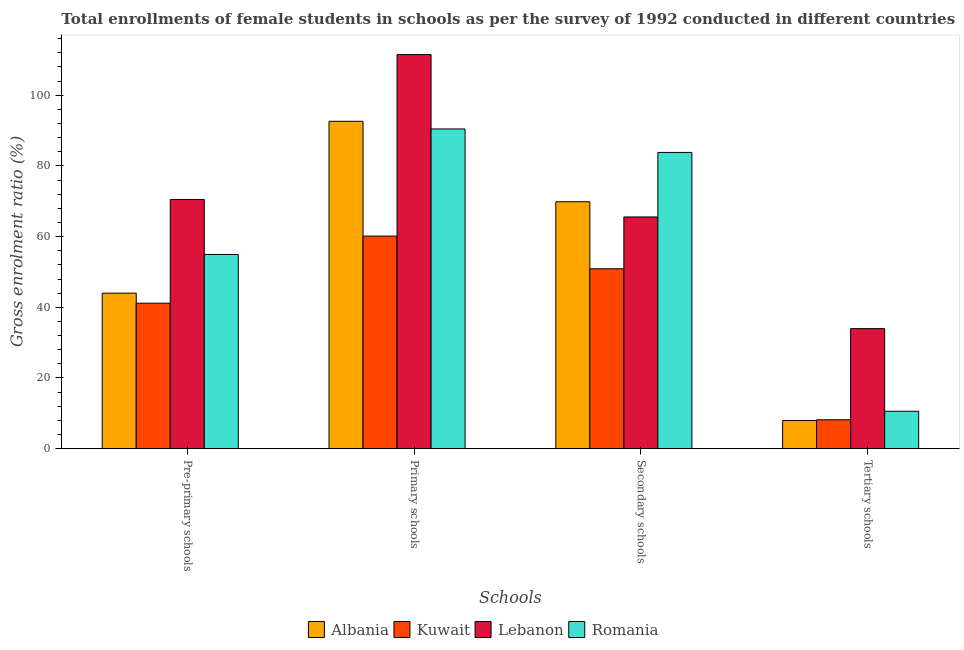How many different coloured bars are there?
Offer a very short reply. 4. How many groups of bars are there?
Provide a short and direct response. 4. How many bars are there on the 1st tick from the left?
Offer a terse response. 4. What is the label of the 4th group of bars from the left?
Your answer should be very brief. Tertiary schools. What is the gross enrolment ratio(female) in tertiary schools in Romania?
Provide a short and direct response. 10.59. Across all countries, what is the maximum gross enrolment ratio(female) in pre-primary schools?
Provide a succinct answer. 70.51. Across all countries, what is the minimum gross enrolment ratio(female) in tertiary schools?
Provide a succinct answer. 7.96. In which country was the gross enrolment ratio(female) in pre-primary schools maximum?
Your response must be concise. Lebanon. In which country was the gross enrolment ratio(female) in tertiary schools minimum?
Keep it short and to the point. Albania. What is the total gross enrolment ratio(female) in primary schools in the graph?
Provide a succinct answer. 354.71. What is the difference between the gross enrolment ratio(female) in pre-primary schools in Romania and that in Albania?
Your answer should be very brief. 10.95. What is the difference between the gross enrolment ratio(female) in primary schools in Lebanon and the gross enrolment ratio(female) in pre-primary schools in Romania?
Keep it short and to the point. 56.54. What is the average gross enrolment ratio(female) in pre-primary schools per country?
Offer a terse response. 52.65. What is the difference between the gross enrolment ratio(female) in primary schools and gross enrolment ratio(female) in tertiary schools in Romania?
Provide a short and direct response. 79.87. In how many countries, is the gross enrolment ratio(female) in secondary schools greater than 56 %?
Your answer should be very brief. 3. What is the ratio of the gross enrolment ratio(female) in primary schools in Romania to that in Albania?
Your response must be concise. 0.98. Is the gross enrolment ratio(female) in secondary schools in Kuwait less than that in Albania?
Ensure brevity in your answer.  Yes. What is the difference between the highest and the second highest gross enrolment ratio(female) in tertiary schools?
Provide a short and direct response. 23.37. What is the difference between the highest and the lowest gross enrolment ratio(female) in tertiary schools?
Make the answer very short. 26. In how many countries, is the gross enrolment ratio(female) in secondary schools greater than the average gross enrolment ratio(female) in secondary schools taken over all countries?
Give a very brief answer. 2. What does the 3rd bar from the left in Pre-primary schools represents?
Make the answer very short. Lebanon. What does the 3rd bar from the right in Secondary schools represents?
Provide a short and direct response. Kuwait. Is it the case that in every country, the sum of the gross enrolment ratio(female) in pre-primary schools and gross enrolment ratio(female) in primary schools is greater than the gross enrolment ratio(female) in secondary schools?
Make the answer very short. Yes. How many countries are there in the graph?
Give a very brief answer. 4. Does the graph contain any zero values?
Your answer should be compact. No. What is the title of the graph?
Provide a succinct answer. Total enrollments of female students in schools as per the survey of 1992 conducted in different countries. What is the label or title of the X-axis?
Make the answer very short. Schools. What is the Gross enrolment ratio (%) of Albania in Pre-primary schools?
Your answer should be very brief. 44. What is the Gross enrolment ratio (%) in Kuwait in Pre-primary schools?
Provide a short and direct response. 41.16. What is the Gross enrolment ratio (%) in Lebanon in Pre-primary schools?
Ensure brevity in your answer.  70.51. What is the Gross enrolment ratio (%) of Romania in Pre-primary schools?
Offer a very short reply. 54.95. What is the Gross enrolment ratio (%) of Albania in Primary schools?
Provide a succinct answer. 92.62. What is the Gross enrolment ratio (%) in Kuwait in Primary schools?
Your response must be concise. 60.14. What is the Gross enrolment ratio (%) in Lebanon in Primary schools?
Offer a very short reply. 111.49. What is the Gross enrolment ratio (%) of Romania in Primary schools?
Give a very brief answer. 90.46. What is the Gross enrolment ratio (%) of Albania in Secondary schools?
Provide a short and direct response. 69.86. What is the Gross enrolment ratio (%) of Kuwait in Secondary schools?
Make the answer very short. 50.9. What is the Gross enrolment ratio (%) in Lebanon in Secondary schools?
Ensure brevity in your answer.  65.56. What is the Gross enrolment ratio (%) of Romania in Secondary schools?
Offer a terse response. 83.81. What is the Gross enrolment ratio (%) of Albania in Tertiary schools?
Your answer should be compact. 7.96. What is the Gross enrolment ratio (%) of Kuwait in Tertiary schools?
Your response must be concise. 8.18. What is the Gross enrolment ratio (%) in Lebanon in Tertiary schools?
Provide a short and direct response. 33.96. What is the Gross enrolment ratio (%) of Romania in Tertiary schools?
Offer a terse response. 10.59. Across all Schools, what is the maximum Gross enrolment ratio (%) in Albania?
Your answer should be compact. 92.62. Across all Schools, what is the maximum Gross enrolment ratio (%) in Kuwait?
Offer a terse response. 60.14. Across all Schools, what is the maximum Gross enrolment ratio (%) of Lebanon?
Your response must be concise. 111.49. Across all Schools, what is the maximum Gross enrolment ratio (%) of Romania?
Ensure brevity in your answer.  90.46. Across all Schools, what is the minimum Gross enrolment ratio (%) of Albania?
Your answer should be very brief. 7.96. Across all Schools, what is the minimum Gross enrolment ratio (%) of Kuwait?
Keep it short and to the point. 8.18. Across all Schools, what is the minimum Gross enrolment ratio (%) in Lebanon?
Give a very brief answer. 33.96. Across all Schools, what is the minimum Gross enrolment ratio (%) of Romania?
Provide a succinct answer. 10.59. What is the total Gross enrolment ratio (%) of Albania in the graph?
Your answer should be compact. 214.44. What is the total Gross enrolment ratio (%) in Kuwait in the graph?
Your answer should be very brief. 160.38. What is the total Gross enrolment ratio (%) in Lebanon in the graph?
Ensure brevity in your answer.  281.52. What is the total Gross enrolment ratio (%) in Romania in the graph?
Your answer should be very brief. 239.81. What is the difference between the Gross enrolment ratio (%) in Albania in Pre-primary schools and that in Primary schools?
Ensure brevity in your answer.  -48.62. What is the difference between the Gross enrolment ratio (%) in Kuwait in Pre-primary schools and that in Primary schools?
Keep it short and to the point. -18.98. What is the difference between the Gross enrolment ratio (%) of Lebanon in Pre-primary schools and that in Primary schools?
Keep it short and to the point. -40.98. What is the difference between the Gross enrolment ratio (%) in Romania in Pre-primary schools and that in Primary schools?
Offer a very short reply. -35.5. What is the difference between the Gross enrolment ratio (%) in Albania in Pre-primary schools and that in Secondary schools?
Offer a very short reply. -25.86. What is the difference between the Gross enrolment ratio (%) in Kuwait in Pre-primary schools and that in Secondary schools?
Provide a short and direct response. -9.74. What is the difference between the Gross enrolment ratio (%) in Lebanon in Pre-primary schools and that in Secondary schools?
Give a very brief answer. 4.95. What is the difference between the Gross enrolment ratio (%) of Romania in Pre-primary schools and that in Secondary schools?
Provide a short and direct response. -28.86. What is the difference between the Gross enrolment ratio (%) of Albania in Pre-primary schools and that in Tertiary schools?
Your answer should be compact. 36.03. What is the difference between the Gross enrolment ratio (%) of Kuwait in Pre-primary schools and that in Tertiary schools?
Offer a very short reply. 32.98. What is the difference between the Gross enrolment ratio (%) of Lebanon in Pre-primary schools and that in Tertiary schools?
Ensure brevity in your answer.  36.55. What is the difference between the Gross enrolment ratio (%) in Romania in Pre-primary schools and that in Tertiary schools?
Offer a very short reply. 44.36. What is the difference between the Gross enrolment ratio (%) of Albania in Primary schools and that in Secondary schools?
Offer a very short reply. 22.76. What is the difference between the Gross enrolment ratio (%) in Kuwait in Primary schools and that in Secondary schools?
Provide a short and direct response. 9.25. What is the difference between the Gross enrolment ratio (%) of Lebanon in Primary schools and that in Secondary schools?
Provide a succinct answer. 45.94. What is the difference between the Gross enrolment ratio (%) of Romania in Primary schools and that in Secondary schools?
Make the answer very short. 6.64. What is the difference between the Gross enrolment ratio (%) in Albania in Primary schools and that in Tertiary schools?
Keep it short and to the point. 84.66. What is the difference between the Gross enrolment ratio (%) in Kuwait in Primary schools and that in Tertiary schools?
Ensure brevity in your answer.  51.96. What is the difference between the Gross enrolment ratio (%) in Lebanon in Primary schools and that in Tertiary schools?
Your response must be concise. 77.53. What is the difference between the Gross enrolment ratio (%) of Romania in Primary schools and that in Tertiary schools?
Make the answer very short. 79.87. What is the difference between the Gross enrolment ratio (%) of Albania in Secondary schools and that in Tertiary schools?
Keep it short and to the point. 61.9. What is the difference between the Gross enrolment ratio (%) of Kuwait in Secondary schools and that in Tertiary schools?
Your response must be concise. 42.72. What is the difference between the Gross enrolment ratio (%) of Lebanon in Secondary schools and that in Tertiary schools?
Give a very brief answer. 31.59. What is the difference between the Gross enrolment ratio (%) of Romania in Secondary schools and that in Tertiary schools?
Provide a short and direct response. 73.22. What is the difference between the Gross enrolment ratio (%) in Albania in Pre-primary schools and the Gross enrolment ratio (%) in Kuwait in Primary schools?
Ensure brevity in your answer.  -16.15. What is the difference between the Gross enrolment ratio (%) in Albania in Pre-primary schools and the Gross enrolment ratio (%) in Lebanon in Primary schools?
Ensure brevity in your answer.  -67.5. What is the difference between the Gross enrolment ratio (%) in Albania in Pre-primary schools and the Gross enrolment ratio (%) in Romania in Primary schools?
Ensure brevity in your answer.  -46.46. What is the difference between the Gross enrolment ratio (%) of Kuwait in Pre-primary schools and the Gross enrolment ratio (%) of Lebanon in Primary schools?
Your answer should be very brief. -70.33. What is the difference between the Gross enrolment ratio (%) of Kuwait in Pre-primary schools and the Gross enrolment ratio (%) of Romania in Primary schools?
Your answer should be compact. -49.29. What is the difference between the Gross enrolment ratio (%) of Lebanon in Pre-primary schools and the Gross enrolment ratio (%) of Romania in Primary schools?
Offer a very short reply. -19.95. What is the difference between the Gross enrolment ratio (%) of Albania in Pre-primary schools and the Gross enrolment ratio (%) of Kuwait in Secondary schools?
Keep it short and to the point. -6.9. What is the difference between the Gross enrolment ratio (%) of Albania in Pre-primary schools and the Gross enrolment ratio (%) of Lebanon in Secondary schools?
Your answer should be very brief. -21.56. What is the difference between the Gross enrolment ratio (%) of Albania in Pre-primary schools and the Gross enrolment ratio (%) of Romania in Secondary schools?
Ensure brevity in your answer.  -39.82. What is the difference between the Gross enrolment ratio (%) in Kuwait in Pre-primary schools and the Gross enrolment ratio (%) in Lebanon in Secondary schools?
Offer a terse response. -24.39. What is the difference between the Gross enrolment ratio (%) in Kuwait in Pre-primary schools and the Gross enrolment ratio (%) in Romania in Secondary schools?
Offer a very short reply. -42.65. What is the difference between the Gross enrolment ratio (%) in Lebanon in Pre-primary schools and the Gross enrolment ratio (%) in Romania in Secondary schools?
Your response must be concise. -13.3. What is the difference between the Gross enrolment ratio (%) in Albania in Pre-primary schools and the Gross enrolment ratio (%) in Kuwait in Tertiary schools?
Your answer should be very brief. 35.82. What is the difference between the Gross enrolment ratio (%) in Albania in Pre-primary schools and the Gross enrolment ratio (%) in Lebanon in Tertiary schools?
Provide a succinct answer. 10.04. What is the difference between the Gross enrolment ratio (%) in Albania in Pre-primary schools and the Gross enrolment ratio (%) in Romania in Tertiary schools?
Offer a terse response. 33.41. What is the difference between the Gross enrolment ratio (%) in Kuwait in Pre-primary schools and the Gross enrolment ratio (%) in Lebanon in Tertiary schools?
Provide a short and direct response. 7.2. What is the difference between the Gross enrolment ratio (%) in Kuwait in Pre-primary schools and the Gross enrolment ratio (%) in Romania in Tertiary schools?
Your answer should be very brief. 30.57. What is the difference between the Gross enrolment ratio (%) in Lebanon in Pre-primary schools and the Gross enrolment ratio (%) in Romania in Tertiary schools?
Offer a terse response. 59.92. What is the difference between the Gross enrolment ratio (%) in Albania in Primary schools and the Gross enrolment ratio (%) in Kuwait in Secondary schools?
Provide a succinct answer. 41.72. What is the difference between the Gross enrolment ratio (%) of Albania in Primary schools and the Gross enrolment ratio (%) of Lebanon in Secondary schools?
Give a very brief answer. 27.06. What is the difference between the Gross enrolment ratio (%) in Albania in Primary schools and the Gross enrolment ratio (%) in Romania in Secondary schools?
Offer a terse response. 8.81. What is the difference between the Gross enrolment ratio (%) in Kuwait in Primary schools and the Gross enrolment ratio (%) in Lebanon in Secondary schools?
Offer a terse response. -5.41. What is the difference between the Gross enrolment ratio (%) of Kuwait in Primary schools and the Gross enrolment ratio (%) of Romania in Secondary schools?
Provide a short and direct response. -23.67. What is the difference between the Gross enrolment ratio (%) in Lebanon in Primary schools and the Gross enrolment ratio (%) in Romania in Secondary schools?
Your response must be concise. 27.68. What is the difference between the Gross enrolment ratio (%) in Albania in Primary schools and the Gross enrolment ratio (%) in Kuwait in Tertiary schools?
Offer a very short reply. 84.44. What is the difference between the Gross enrolment ratio (%) of Albania in Primary schools and the Gross enrolment ratio (%) of Lebanon in Tertiary schools?
Offer a very short reply. 58.66. What is the difference between the Gross enrolment ratio (%) in Albania in Primary schools and the Gross enrolment ratio (%) in Romania in Tertiary schools?
Ensure brevity in your answer.  82.03. What is the difference between the Gross enrolment ratio (%) of Kuwait in Primary schools and the Gross enrolment ratio (%) of Lebanon in Tertiary schools?
Make the answer very short. 26.18. What is the difference between the Gross enrolment ratio (%) in Kuwait in Primary schools and the Gross enrolment ratio (%) in Romania in Tertiary schools?
Offer a terse response. 49.56. What is the difference between the Gross enrolment ratio (%) in Lebanon in Primary schools and the Gross enrolment ratio (%) in Romania in Tertiary schools?
Make the answer very short. 100.91. What is the difference between the Gross enrolment ratio (%) of Albania in Secondary schools and the Gross enrolment ratio (%) of Kuwait in Tertiary schools?
Offer a terse response. 61.68. What is the difference between the Gross enrolment ratio (%) in Albania in Secondary schools and the Gross enrolment ratio (%) in Lebanon in Tertiary schools?
Give a very brief answer. 35.9. What is the difference between the Gross enrolment ratio (%) of Albania in Secondary schools and the Gross enrolment ratio (%) of Romania in Tertiary schools?
Provide a short and direct response. 59.27. What is the difference between the Gross enrolment ratio (%) of Kuwait in Secondary schools and the Gross enrolment ratio (%) of Lebanon in Tertiary schools?
Make the answer very short. 16.94. What is the difference between the Gross enrolment ratio (%) in Kuwait in Secondary schools and the Gross enrolment ratio (%) in Romania in Tertiary schools?
Make the answer very short. 40.31. What is the difference between the Gross enrolment ratio (%) in Lebanon in Secondary schools and the Gross enrolment ratio (%) in Romania in Tertiary schools?
Your answer should be very brief. 54.97. What is the average Gross enrolment ratio (%) in Albania per Schools?
Offer a terse response. 53.61. What is the average Gross enrolment ratio (%) of Kuwait per Schools?
Your answer should be compact. 40.1. What is the average Gross enrolment ratio (%) in Lebanon per Schools?
Give a very brief answer. 70.38. What is the average Gross enrolment ratio (%) of Romania per Schools?
Provide a succinct answer. 59.95. What is the difference between the Gross enrolment ratio (%) of Albania and Gross enrolment ratio (%) of Kuwait in Pre-primary schools?
Give a very brief answer. 2.84. What is the difference between the Gross enrolment ratio (%) of Albania and Gross enrolment ratio (%) of Lebanon in Pre-primary schools?
Give a very brief answer. -26.51. What is the difference between the Gross enrolment ratio (%) in Albania and Gross enrolment ratio (%) in Romania in Pre-primary schools?
Your answer should be very brief. -10.95. What is the difference between the Gross enrolment ratio (%) in Kuwait and Gross enrolment ratio (%) in Lebanon in Pre-primary schools?
Your answer should be very brief. -29.35. What is the difference between the Gross enrolment ratio (%) of Kuwait and Gross enrolment ratio (%) of Romania in Pre-primary schools?
Offer a terse response. -13.79. What is the difference between the Gross enrolment ratio (%) of Lebanon and Gross enrolment ratio (%) of Romania in Pre-primary schools?
Your answer should be very brief. 15.56. What is the difference between the Gross enrolment ratio (%) of Albania and Gross enrolment ratio (%) of Kuwait in Primary schools?
Give a very brief answer. 32.47. What is the difference between the Gross enrolment ratio (%) of Albania and Gross enrolment ratio (%) of Lebanon in Primary schools?
Make the answer very short. -18.87. What is the difference between the Gross enrolment ratio (%) in Albania and Gross enrolment ratio (%) in Romania in Primary schools?
Your response must be concise. 2.16. What is the difference between the Gross enrolment ratio (%) in Kuwait and Gross enrolment ratio (%) in Lebanon in Primary schools?
Your response must be concise. -51.35. What is the difference between the Gross enrolment ratio (%) in Kuwait and Gross enrolment ratio (%) in Romania in Primary schools?
Keep it short and to the point. -30.31. What is the difference between the Gross enrolment ratio (%) in Lebanon and Gross enrolment ratio (%) in Romania in Primary schools?
Offer a very short reply. 21.04. What is the difference between the Gross enrolment ratio (%) of Albania and Gross enrolment ratio (%) of Kuwait in Secondary schools?
Make the answer very short. 18.96. What is the difference between the Gross enrolment ratio (%) of Albania and Gross enrolment ratio (%) of Lebanon in Secondary schools?
Provide a succinct answer. 4.3. What is the difference between the Gross enrolment ratio (%) of Albania and Gross enrolment ratio (%) of Romania in Secondary schools?
Your answer should be compact. -13.95. What is the difference between the Gross enrolment ratio (%) in Kuwait and Gross enrolment ratio (%) in Lebanon in Secondary schools?
Provide a short and direct response. -14.66. What is the difference between the Gross enrolment ratio (%) of Kuwait and Gross enrolment ratio (%) of Romania in Secondary schools?
Give a very brief answer. -32.92. What is the difference between the Gross enrolment ratio (%) of Lebanon and Gross enrolment ratio (%) of Romania in Secondary schools?
Provide a short and direct response. -18.26. What is the difference between the Gross enrolment ratio (%) of Albania and Gross enrolment ratio (%) of Kuwait in Tertiary schools?
Provide a succinct answer. -0.22. What is the difference between the Gross enrolment ratio (%) in Albania and Gross enrolment ratio (%) in Lebanon in Tertiary schools?
Give a very brief answer. -26. What is the difference between the Gross enrolment ratio (%) in Albania and Gross enrolment ratio (%) in Romania in Tertiary schools?
Offer a very short reply. -2.62. What is the difference between the Gross enrolment ratio (%) in Kuwait and Gross enrolment ratio (%) in Lebanon in Tertiary schools?
Keep it short and to the point. -25.78. What is the difference between the Gross enrolment ratio (%) in Kuwait and Gross enrolment ratio (%) in Romania in Tertiary schools?
Provide a succinct answer. -2.41. What is the difference between the Gross enrolment ratio (%) in Lebanon and Gross enrolment ratio (%) in Romania in Tertiary schools?
Your answer should be very brief. 23.37. What is the ratio of the Gross enrolment ratio (%) in Albania in Pre-primary schools to that in Primary schools?
Ensure brevity in your answer.  0.47. What is the ratio of the Gross enrolment ratio (%) of Kuwait in Pre-primary schools to that in Primary schools?
Your response must be concise. 0.68. What is the ratio of the Gross enrolment ratio (%) in Lebanon in Pre-primary schools to that in Primary schools?
Offer a very short reply. 0.63. What is the ratio of the Gross enrolment ratio (%) in Romania in Pre-primary schools to that in Primary schools?
Make the answer very short. 0.61. What is the ratio of the Gross enrolment ratio (%) of Albania in Pre-primary schools to that in Secondary schools?
Offer a very short reply. 0.63. What is the ratio of the Gross enrolment ratio (%) in Kuwait in Pre-primary schools to that in Secondary schools?
Make the answer very short. 0.81. What is the ratio of the Gross enrolment ratio (%) in Lebanon in Pre-primary schools to that in Secondary schools?
Provide a succinct answer. 1.08. What is the ratio of the Gross enrolment ratio (%) in Romania in Pre-primary schools to that in Secondary schools?
Keep it short and to the point. 0.66. What is the ratio of the Gross enrolment ratio (%) in Albania in Pre-primary schools to that in Tertiary schools?
Your response must be concise. 5.53. What is the ratio of the Gross enrolment ratio (%) of Kuwait in Pre-primary schools to that in Tertiary schools?
Your answer should be compact. 5.03. What is the ratio of the Gross enrolment ratio (%) in Lebanon in Pre-primary schools to that in Tertiary schools?
Your answer should be very brief. 2.08. What is the ratio of the Gross enrolment ratio (%) in Romania in Pre-primary schools to that in Tertiary schools?
Give a very brief answer. 5.19. What is the ratio of the Gross enrolment ratio (%) of Albania in Primary schools to that in Secondary schools?
Provide a short and direct response. 1.33. What is the ratio of the Gross enrolment ratio (%) of Kuwait in Primary schools to that in Secondary schools?
Your response must be concise. 1.18. What is the ratio of the Gross enrolment ratio (%) in Lebanon in Primary schools to that in Secondary schools?
Your answer should be very brief. 1.7. What is the ratio of the Gross enrolment ratio (%) of Romania in Primary schools to that in Secondary schools?
Your answer should be very brief. 1.08. What is the ratio of the Gross enrolment ratio (%) in Albania in Primary schools to that in Tertiary schools?
Keep it short and to the point. 11.63. What is the ratio of the Gross enrolment ratio (%) of Kuwait in Primary schools to that in Tertiary schools?
Your answer should be compact. 7.35. What is the ratio of the Gross enrolment ratio (%) of Lebanon in Primary schools to that in Tertiary schools?
Provide a succinct answer. 3.28. What is the ratio of the Gross enrolment ratio (%) of Romania in Primary schools to that in Tertiary schools?
Offer a terse response. 8.54. What is the ratio of the Gross enrolment ratio (%) in Albania in Secondary schools to that in Tertiary schools?
Keep it short and to the point. 8.77. What is the ratio of the Gross enrolment ratio (%) of Kuwait in Secondary schools to that in Tertiary schools?
Provide a short and direct response. 6.22. What is the ratio of the Gross enrolment ratio (%) of Lebanon in Secondary schools to that in Tertiary schools?
Offer a terse response. 1.93. What is the ratio of the Gross enrolment ratio (%) of Romania in Secondary schools to that in Tertiary schools?
Give a very brief answer. 7.92. What is the difference between the highest and the second highest Gross enrolment ratio (%) of Albania?
Keep it short and to the point. 22.76. What is the difference between the highest and the second highest Gross enrolment ratio (%) in Kuwait?
Your answer should be compact. 9.25. What is the difference between the highest and the second highest Gross enrolment ratio (%) in Lebanon?
Offer a very short reply. 40.98. What is the difference between the highest and the second highest Gross enrolment ratio (%) in Romania?
Provide a succinct answer. 6.64. What is the difference between the highest and the lowest Gross enrolment ratio (%) in Albania?
Your answer should be compact. 84.66. What is the difference between the highest and the lowest Gross enrolment ratio (%) in Kuwait?
Provide a short and direct response. 51.96. What is the difference between the highest and the lowest Gross enrolment ratio (%) of Lebanon?
Your response must be concise. 77.53. What is the difference between the highest and the lowest Gross enrolment ratio (%) in Romania?
Offer a very short reply. 79.87. 